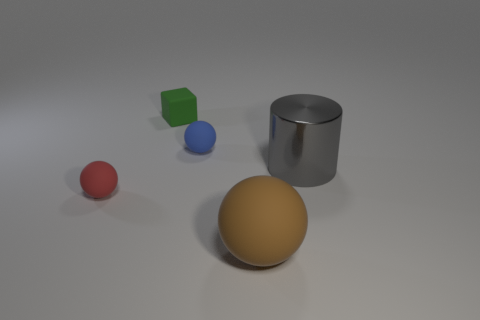Subtract all brown rubber spheres. How many spheres are left? 2 Add 1 tiny brown metallic objects. How many objects exist? 6 Subtract all cylinders. How many objects are left? 4 Subtract all purple spheres. Subtract all blue cylinders. How many spheres are left? 3 Subtract all gray balls. How many brown cylinders are left? 0 Subtract all balls. Subtract all big brown objects. How many objects are left? 1 Add 4 blue rubber things. How many blue rubber things are left? 5 Add 4 tiny gray metallic things. How many tiny gray metallic things exist? 4 Subtract 0 gray balls. How many objects are left? 5 